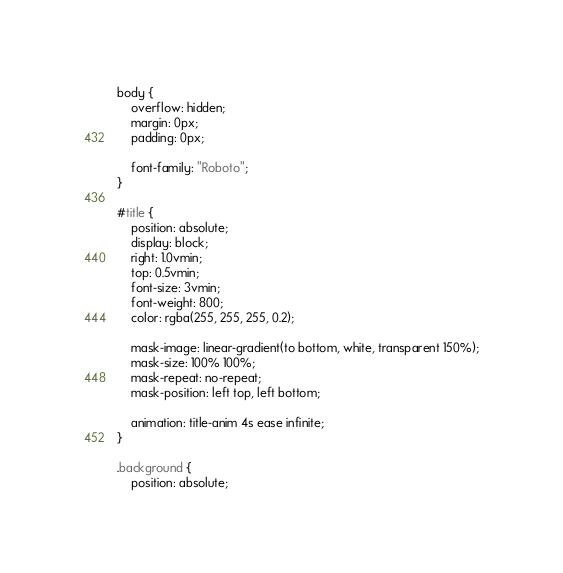<code> <loc_0><loc_0><loc_500><loc_500><_CSS_>body {
	overflow: hidden;
	margin: 0px;
	padding: 0px;

	font-family: "Roboto";
}

#title {
	position: absolute;
	display: block;
	right: 1.0vmin;
	top: 0.5vmin;
	font-size: 3vmin;
	font-weight: 800;
	color: rgba(255, 255, 255, 0.2);

	mask-image: linear-gradient(to bottom, white, transparent 150%);
	mask-size: 100% 100%;
	mask-repeat: no-repeat;
	mask-position: left top, left bottom;

	animation: title-anim 4s ease infinite;
}

.background {
	position: absolute;</code> 